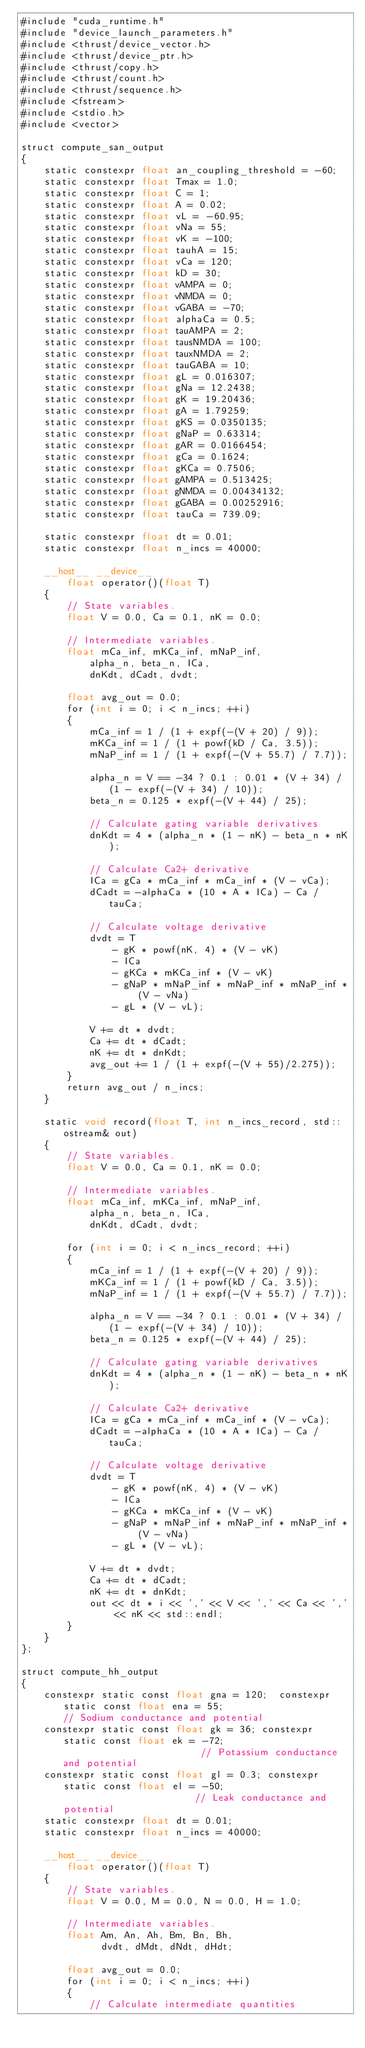<code> <loc_0><loc_0><loc_500><loc_500><_Cuda_>#include "cuda_runtime.h"
#include "device_launch_parameters.h"
#include <thrust/device_vector.h>
#include <thrust/device_ptr.h>
#include <thrust/copy.h>
#include <thrust/count.h>
#include <thrust/sequence.h>
#include <fstream>
#include <stdio.h>
#include <vector>

struct compute_san_output
{
    static constexpr float an_coupling_threshold = -60;
    static constexpr float Tmax = 1.0;
    static constexpr float C = 1;
    static constexpr float A = 0.02;
    static constexpr float vL = -60.95;
    static constexpr float vNa = 55;
    static constexpr float vK = -100;
    static constexpr float tauhA = 15;
    static constexpr float vCa = 120;
    static constexpr float kD = 30;
    static constexpr float vAMPA = 0;
    static constexpr float vNMDA = 0;
    static constexpr float vGABA = -70;
    static constexpr float alphaCa = 0.5;
    static constexpr float tauAMPA = 2;
    static constexpr float tausNMDA = 100;
    static constexpr float tauxNMDA = 2;
    static constexpr float tauGABA = 10;
    static constexpr float gL = 0.016307;
    static constexpr float gNa = 12.2438;
    static constexpr float gK = 19.20436;
    static constexpr float gA = 1.79259;
    static constexpr float gKS = 0.0350135;
    static constexpr float gNaP = 0.63314;
    static constexpr float gAR = 0.0166454;
    static constexpr float gCa = 0.1624;
    static constexpr float gKCa = 0.7506;
    static constexpr float gAMPA = 0.513425;
    static constexpr float gNMDA = 0.00434132;
    static constexpr float gGABA = 0.00252916;
    static constexpr float tauCa = 739.09;

    static constexpr float dt = 0.01;
    static constexpr float n_incs = 40000;

    __host__ __device__
        float operator()(float T)
    {
        // State variables.
        float V = 0.0, Ca = 0.1, nK = 0.0;

        // Intermediate variables.
        float mCa_inf, mKCa_inf, mNaP_inf,
            alpha_n, beta_n, ICa,
            dnKdt, dCadt, dvdt;

        float avg_out = 0.0;
        for (int i = 0; i < n_incs; ++i)
        {
            mCa_inf = 1 / (1 + expf(-(V + 20) / 9));
            mKCa_inf = 1 / (1 + powf(kD / Ca, 3.5));
            mNaP_inf = 1 / (1 + expf(-(V + 55.7) / 7.7));

            alpha_n = V == -34 ? 0.1 : 0.01 * (V + 34) / (1 - expf(-(V + 34) / 10));
            beta_n = 0.125 * expf(-(V + 44) / 25);

            // Calculate gating variable derivatives
            dnKdt = 4 * (alpha_n * (1 - nK) - beta_n * nK);

            // Calculate Ca2+ derivative
            ICa = gCa * mCa_inf * mCa_inf * (V - vCa);
            dCadt = -alphaCa * (10 * A * ICa) - Ca / tauCa;

            // Calculate voltage derivative
            dvdt = T
                - gK * powf(nK, 4) * (V - vK)
                - ICa
                - gKCa * mKCa_inf * (V - vK)
                - gNaP * mNaP_inf * mNaP_inf * mNaP_inf * (V - vNa)
                - gL * (V - vL);

            V += dt * dvdt;
            Ca += dt * dCadt;
            nK += dt * dnKdt;
            avg_out += 1 / (1 + expf(-(V + 55)/2.275));
        }
        return avg_out / n_incs;
    }

    static void record(float T, int n_incs_record, std::ostream& out)
    {
        // State variables.
        float V = 0.0, Ca = 0.1, nK = 0.0;

        // Intermediate variables.
        float mCa_inf, mKCa_inf, mNaP_inf,
            alpha_n, beta_n, ICa,
            dnKdt, dCadt, dvdt;

        for (int i = 0; i < n_incs_record; ++i)
        {
            mCa_inf = 1 / (1 + expf(-(V + 20) / 9));
            mKCa_inf = 1 / (1 + powf(kD / Ca, 3.5));
            mNaP_inf = 1 / (1 + expf(-(V + 55.7) / 7.7));

            alpha_n = V == -34 ? 0.1 : 0.01 * (V + 34) / (1 - expf(-(V + 34) / 10));
            beta_n = 0.125 * expf(-(V + 44) / 25);

            // Calculate gating variable derivatives
            dnKdt = 4 * (alpha_n * (1 - nK) - beta_n * nK);

            // Calculate Ca2+ derivative
            ICa = gCa * mCa_inf * mCa_inf * (V - vCa);
            dCadt = -alphaCa * (10 * A * ICa) - Ca / tauCa;

            // Calculate voltage derivative
            dvdt = T
                - gK * powf(nK, 4) * (V - vK)
                - ICa
                - gKCa * mKCa_inf * (V - vK)
                - gNaP * mNaP_inf * mNaP_inf * mNaP_inf * (V - vNa)
                - gL * (V - vL);

            V += dt * dvdt;
            Ca += dt * dCadt;
            nK += dt * dnKdt;
            out << dt * i << ',' << V << ',' << Ca << ',' << nK << std::endl;
        }
    }
};

struct compute_hh_output
{
    constexpr static const float gna = 120;  constexpr static const float ena = 55;                      // Sodium conductance and potential
    constexpr static const float gk = 36; constexpr static const float ek = -72;                         // Potassium conductance and potential
    constexpr static const float gl = 0.3; constexpr static const float el = -50;                        // Leak conductance and potential
    static constexpr float dt = 0.01;
    static constexpr float n_incs = 40000;

    __host__ __device__
        float operator()(float T)
    {
        // State variables.
        float V = 0.0, M = 0.0, N = 0.0, H = 1.0;

        // Intermediate variables.
        float Am, An, Ah, Bm, Bn, Bh,
              dvdt, dMdt, dNdt, dHdt;

        float avg_out = 0.0;
        for (int i = 0; i < n_incs; ++i)
        {
            // Calculate intermediate quantities</code> 